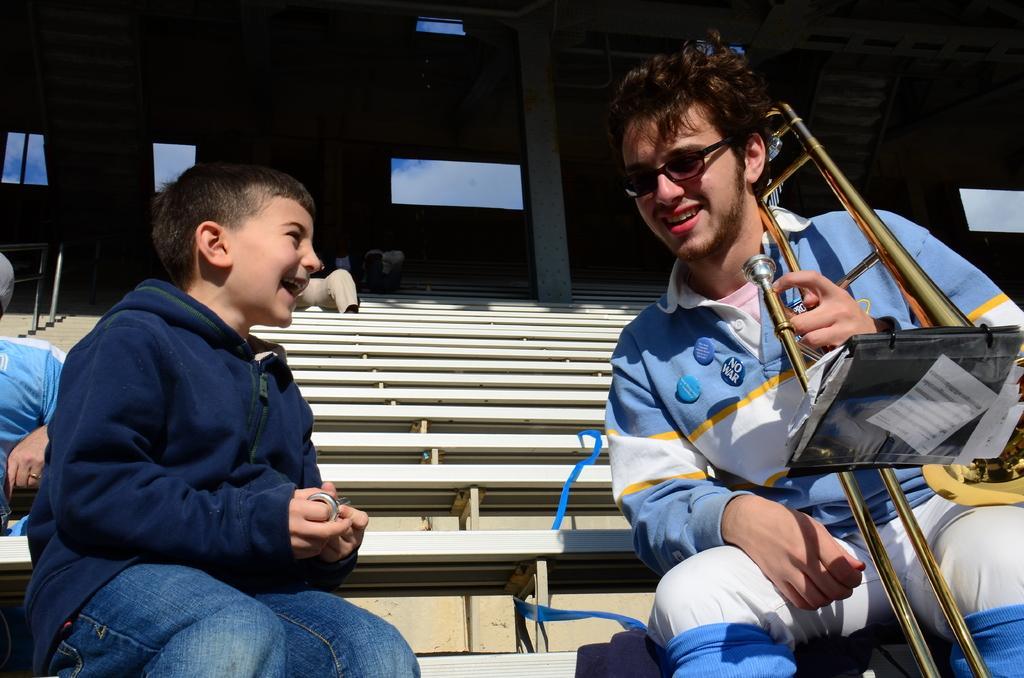Could you give a brief overview of what you see in this image? On the right side of the image we can see a man is sitting and holding a musical instrument, in-front of him we can see a file. On the left side of the image we can see two people are sitting. In the background of the image we can see the stairs, windows, pole and some people are sitting on the stairs. 